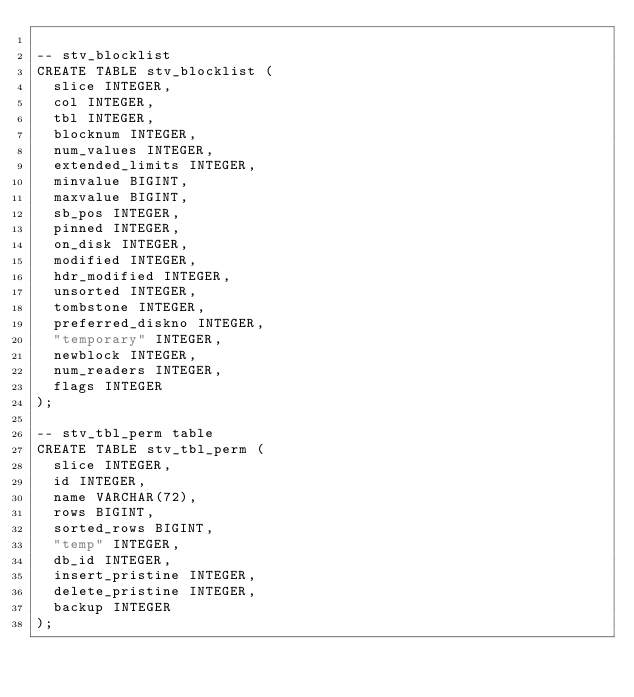<code> <loc_0><loc_0><loc_500><loc_500><_SQL_>
-- stv_blocklist
CREATE TABLE stv_blocklist (
	slice INTEGER,
	col INTEGER,
	tbl INTEGER,
	blocknum INTEGER,
	num_values INTEGER,
	extended_limits INTEGER,
	minvalue BIGINT,
	maxvalue BIGINT,
	sb_pos INTEGER,
	pinned INTEGER,
	on_disk INTEGER,
	modified INTEGER,
	hdr_modified INTEGER,
	unsorted INTEGER,
	tombstone INTEGER,
	preferred_diskno INTEGER,
	"temporary" INTEGER,
	newblock INTEGER,
	num_readers INTEGER,
	flags INTEGER
);

-- stv_tbl_perm table
CREATE TABLE stv_tbl_perm (
	slice INTEGER,
	id INTEGER,
	name VARCHAR(72),
	rows BIGINT,
	sorted_rows BIGINT,
	"temp" INTEGER,
	db_id INTEGER,
	insert_pristine INTEGER,
	delete_pristine INTEGER,
	backup INTEGER
);
</code> 